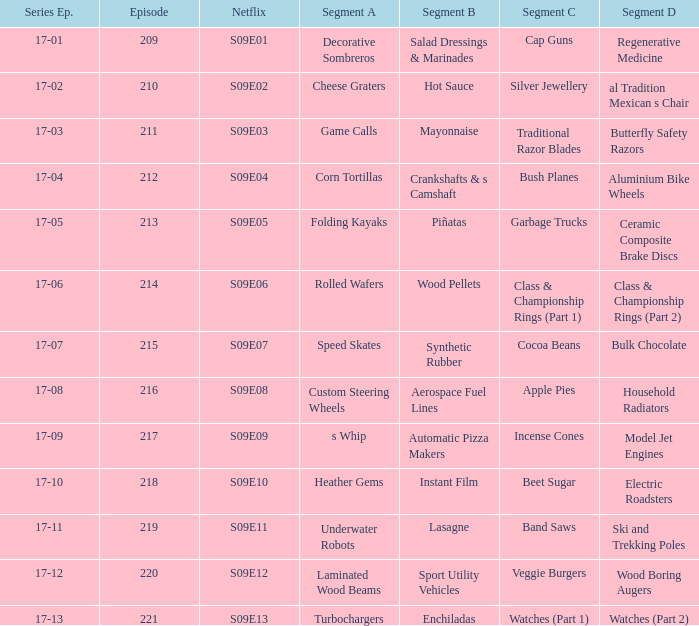What is the netflix episode that includes segment b of aerospace fuel lines? S09E08. 